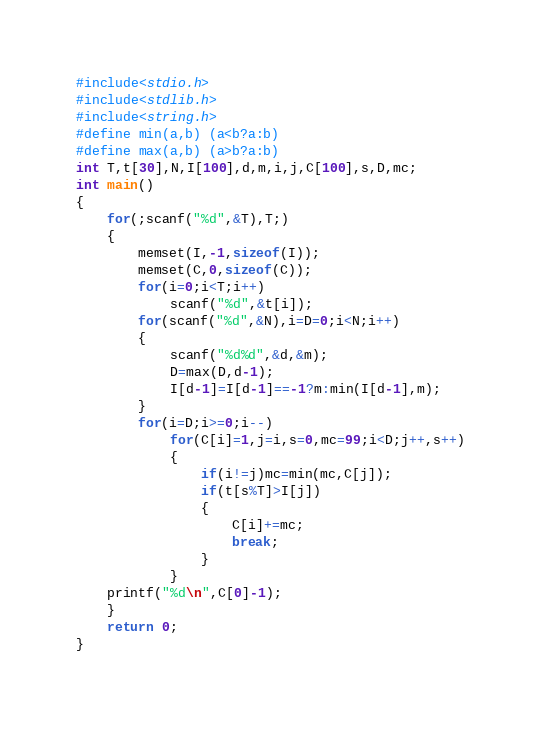<code> <loc_0><loc_0><loc_500><loc_500><_C_>#include<stdio.h>
#include<stdlib.h>
#include<string.h>
#define min(a,b) (a<b?a:b)
#define max(a,b) (a>b?a:b)
int T,t[30],N,I[100],d,m,i,j,C[100],s,D,mc;
int main()
{
	for(;scanf("%d",&T),T;)
	{
		memset(I,-1,sizeof(I));
		memset(C,0,sizeof(C));
		for(i=0;i<T;i++)
			scanf("%d",&t[i]);
		for(scanf("%d",&N),i=D=0;i<N;i++)
		{
			scanf("%d%d",&d,&m);
			D=max(D,d-1);
			I[d-1]=I[d-1]==-1?m:min(I[d-1],m);
		}
		for(i=D;i>=0;i--)
			for(C[i]=1,j=i,s=0,mc=99;i<D;j++,s++)
			{
				if(i!=j)mc=min(mc,C[j]);
				if(t[s%T]>I[j])
				{
					C[i]+=mc;
					break;
				}
			}
	printf("%d\n",C[0]-1);
	}
	return 0;
}</code> 